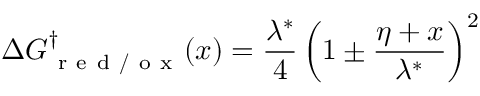Convert formula to latex. <formula><loc_0><loc_0><loc_500><loc_500>\Delta G _ { r e d / o x } ^ { \dag } ( x ) = \frac { \lambda ^ { * } } { 4 } \left ( 1 \pm \frac { \eta + x } { \lambda ^ { * } } \right ) ^ { 2 }</formula> 